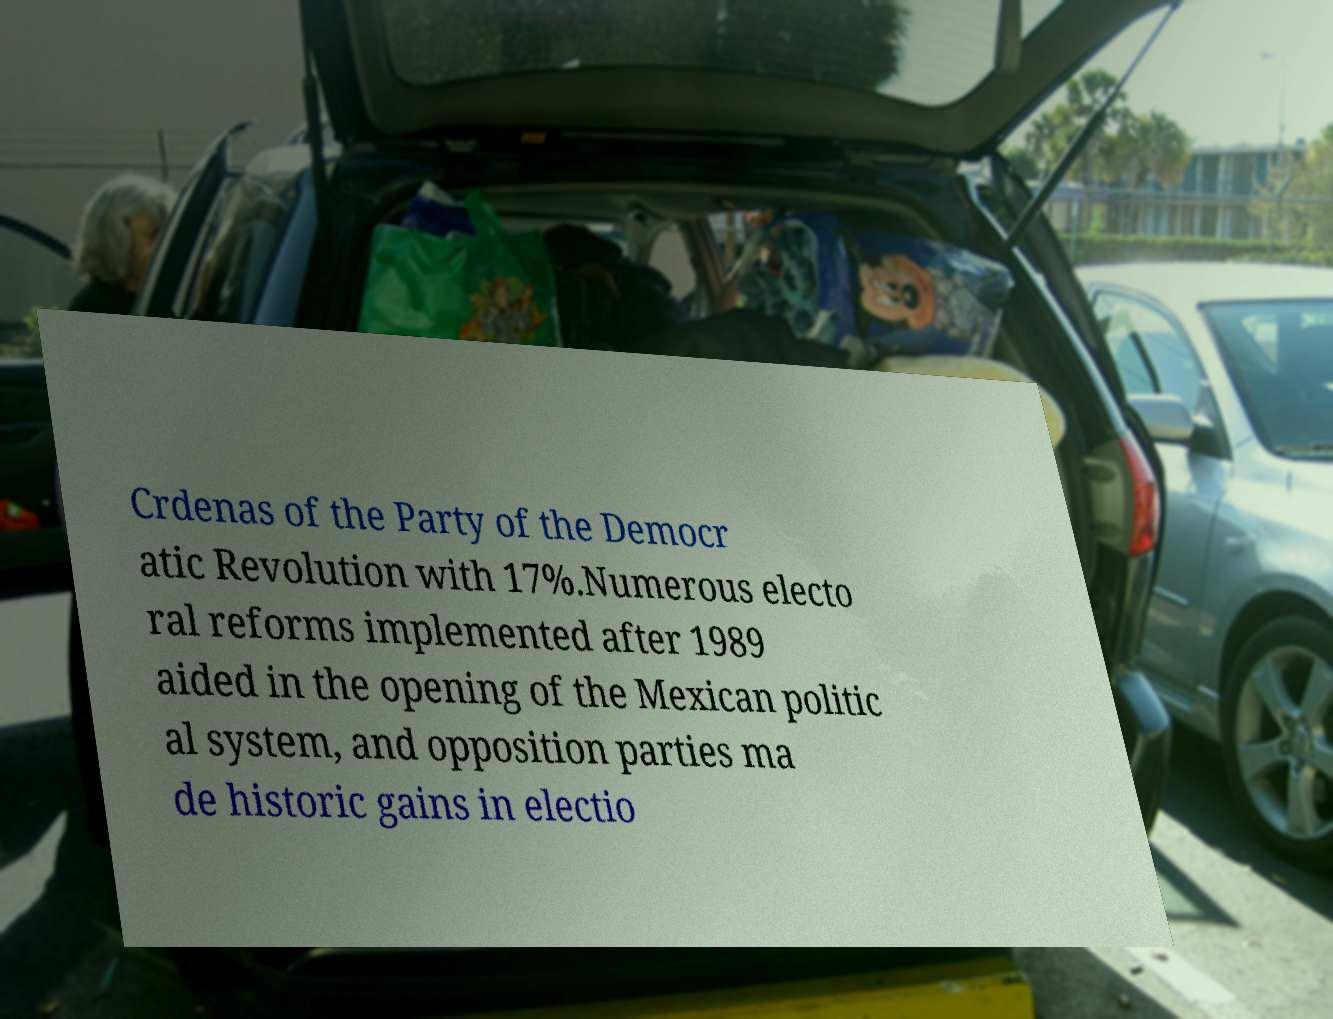Please identify and transcribe the text found in this image. Crdenas of the Party of the Democr atic Revolution with 17%.Numerous electo ral reforms implemented after 1989 aided in the opening of the Mexican politic al system, and opposition parties ma de historic gains in electio 